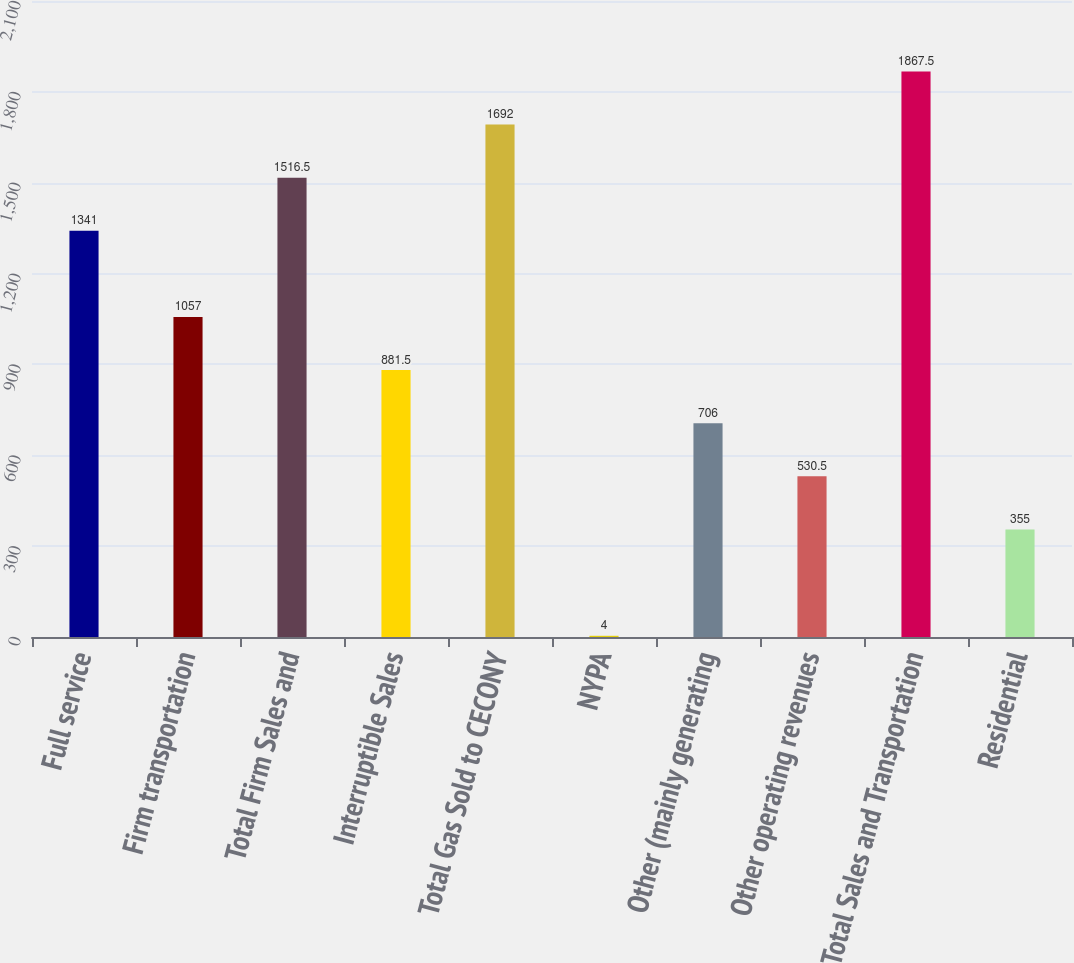Convert chart to OTSL. <chart><loc_0><loc_0><loc_500><loc_500><bar_chart><fcel>Full service<fcel>Firm transportation<fcel>Total Firm Sales and<fcel>Interruptible Sales<fcel>Total Gas Sold to CECONY<fcel>NYPA<fcel>Other (mainly generating<fcel>Other operating revenues<fcel>Total Sales and Transportation<fcel>Residential<nl><fcel>1341<fcel>1057<fcel>1516.5<fcel>881.5<fcel>1692<fcel>4<fcel>706<fcel>530.5<fcel>1867.5<fcel>355<nl></chart> 